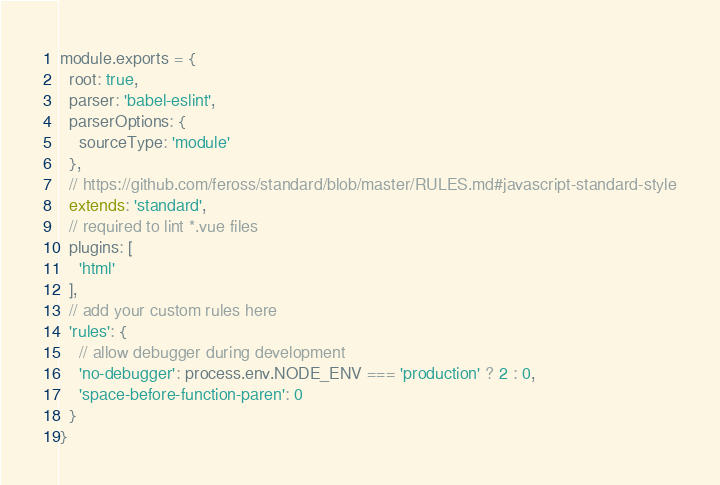<code> <loc_0><loc_0><loc_500><loc_500><_JavaScript_>module.exports = {
  root: true,
  parser: 'babel-eslint',
  parserOptions: {
    sourceType: 'module'
  },
  // https://github.com/feross/standard/blob/master/RULES.md#javascript-standard-style
  extends: 'standard',
  // required to lint *.vue files
  plugins: [
    'html'
  ],
  // add your custom rules here
  'rules': {
    // allow debugger during development
    'no-debugger': process.env.NODE_ENV === 'production' ? 2 : 0,
    'space-before-function-paren': 0
  }
}
</code> 